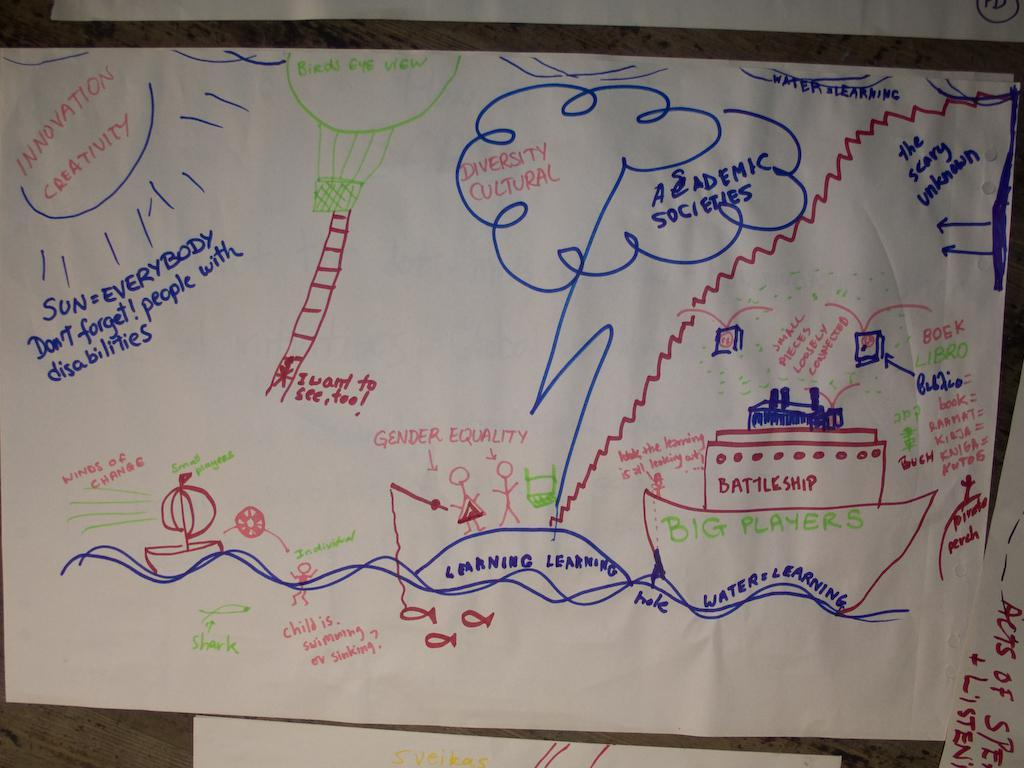<image>
Give a short and clear explanation of the subsequent image. the word creativity that is on a white paper 